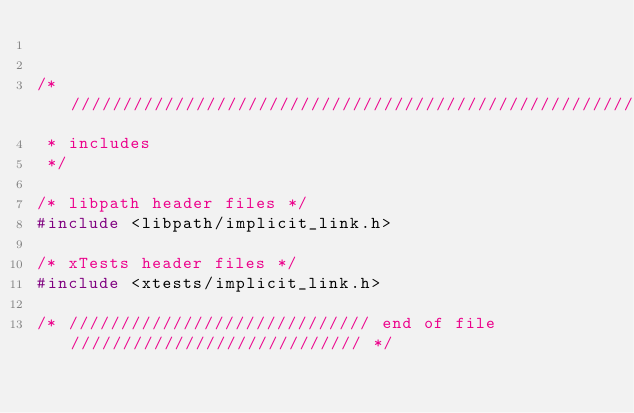<code> <loc_0><loc_0><loc_500><loc_500><_C++_>

/* /////////////////////////////////////////////////////////////////////////
 * includes
 */

/* libpath header files */
#include <libpath/implicit_link.h>

/* xTests header files */
#include <xtests/implicit_link.h>

/* ///////////////////////////// end of file //////////////////////////// */
</code> 